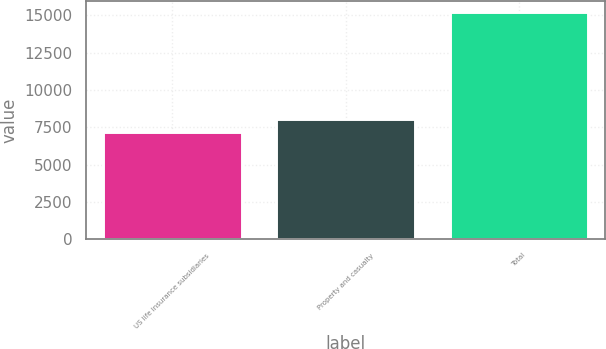Convert chart. <chart><loc_0><loc_0><loc_500><loc_500><bar_chart><fcel>US life insurance subsidiaries<fcel>Property and casualty<fcel>Total<nl><fcel>7157<fcel>8069<fcel>15226<nl></chart> 